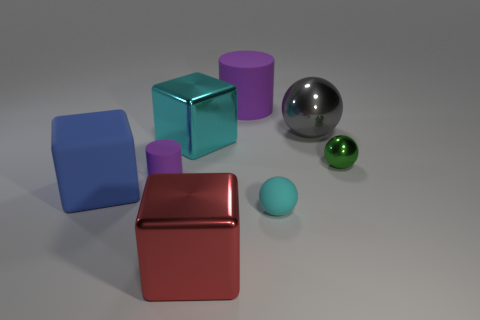Is the color of the small rubber ball the same as the big sphere?
Provide a succinct answer. No. Is there any other thing that is made of the same material as the tiny purple object?
Provide a short and direct response. Yes. There is a small cyan thing that is the same material as the large purple object; what is its shape?
Offer a very short reply. Sphere. Is there any other thing that has the same color as the tiny shiny ball?
Make the answer very short. No. What color is the tiny rubber thing on the left side of the cylinder behind the big gray object?
Your response must be concise. Purple. What is the large thing that is right of the tiny cyan rubber sphere left of the metallic thing to the right of the gray thing made of?
Your response must be concise. Metal. How many other cubes are the same size as the blue block?
Offer a terse response. 2. What is the thing that is behind the small metal ball and left of the red cube made of?
Give a very brief answer. Metal. There is a gray metallic object; what number of red metal things are in front of it?
Your answer should be very brief. 1. There is a gray metallic thing; is it the same shape as the tiny rubber thing that is behind the small cyan rubber object?
Ensure brevity in your answer.  No. 